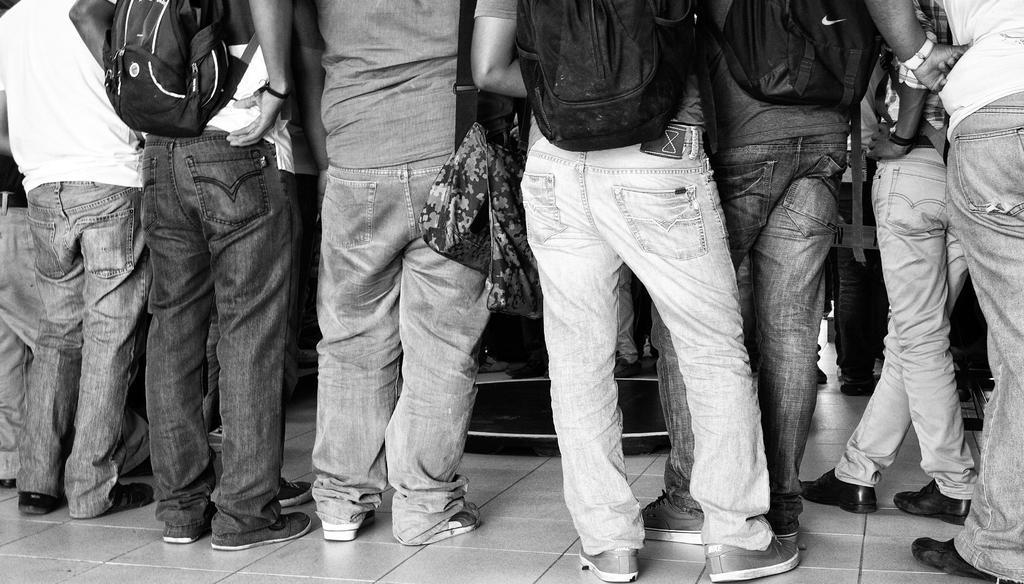Describe this image in one or two sentences. It looks like a black and white picture. We can see there are groups of people standing on the path and we can see the only person's legs. 